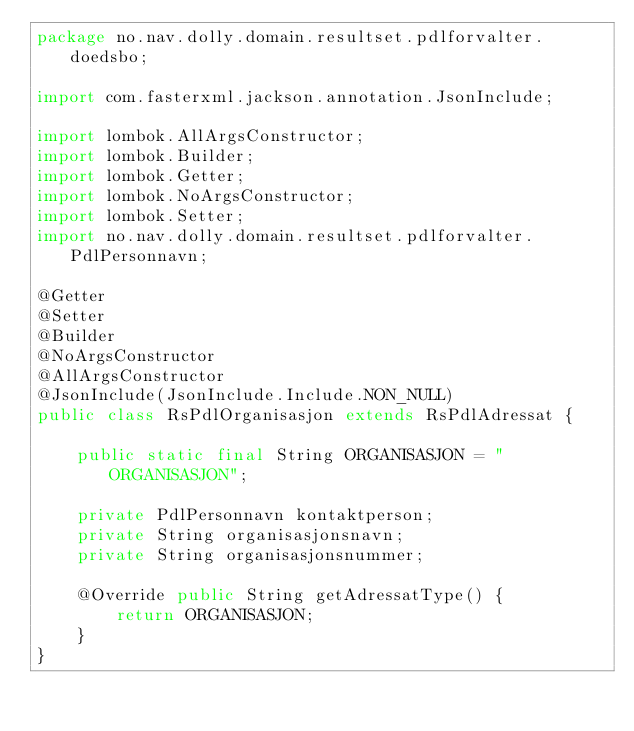<code> <loc_0><loc_0><loc_500><loc_500><_Java_>package no.nav.dolly.domain.resultset.pdlforvalter.doedsbo;

import com.fasterxml.jackson.annotation.JsonInclude;

import lombok.AllArgsConstructor;
import lombok.Builder;
import lombok.Getter;
import lombok.NoArgsConstructor;
import lombok.Setter;
import no.nav.dolly.domain.resultset.pdlforvalter.PdlPersonnavn;

@Getter
@Setter
@Builder
@NoArgsConstructor
@AllArgsConstructor
@JsonInclude(JsonInclude.Include.NON_NULL)
public class RsPdlOrganisasjon extends RsPdlAdressat {

    public static final String ORGANISASJON = "ORGANISASJON";

    private PdlPersonnavn kontaktperson;
    private String organisasjonsnavn;
    private String organisasjonsnummer;

    @Override public String getAdressatType() {
        return ORGANISASJON;
    }
}
</code> 